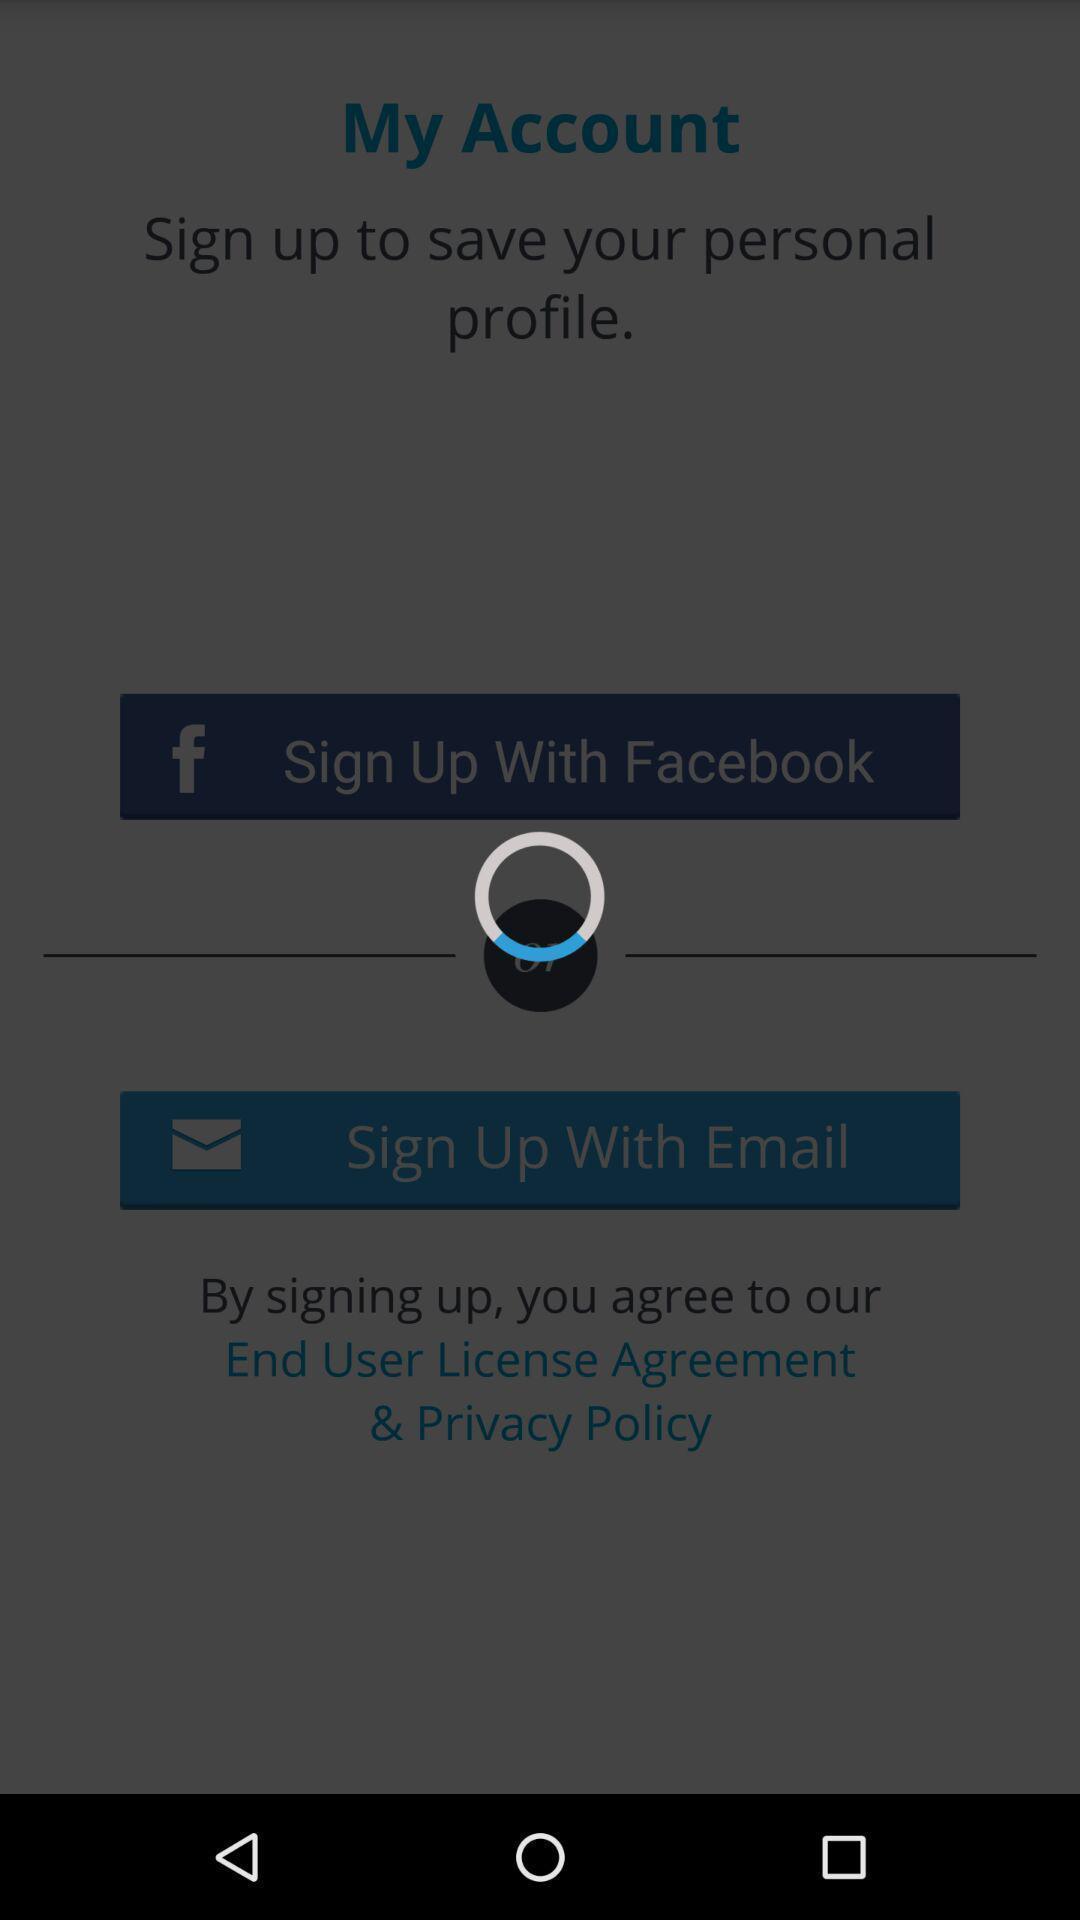Describe the content in this image. Screen displaying a loading icon in sign up page. 